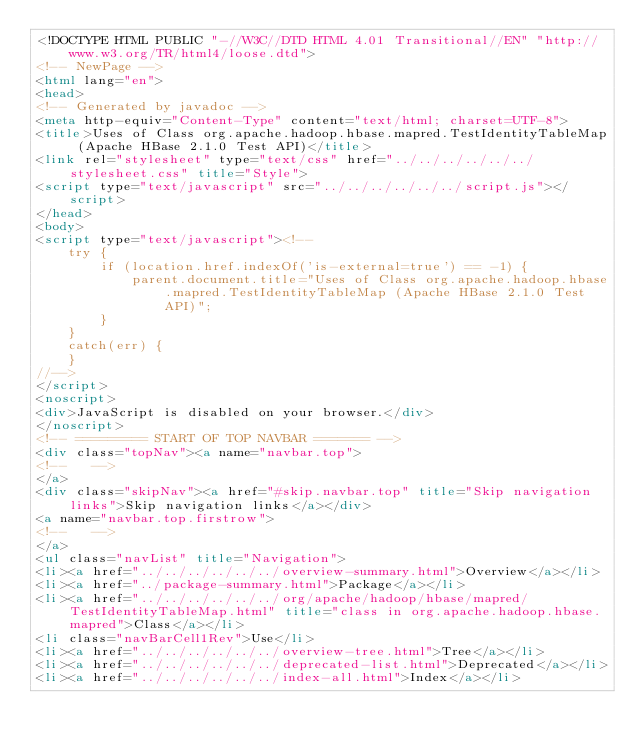<code> <loc_0><loc_0><loc_500><loc_500><_HTML_><!DOCTYPE HTML PUBLIC "-//W3C//DTD HTML 4.01 Transitional//EN" "http://www.w3.org/TR/html4/loose.dtd">
<!-- NewPage -->
<html lang="en">
<head>
<!-- Generated by javadoc -->
<meta http-equiv="Content-Type" content="text/html; charset=UTF-8">
<title>Uses of Class org.apache.hadoop.hbase.mapred.TestIdentityTableMap (Apache HBase 2.1.0 Test API)</title>
<link rel="stylesheet" type="text/css" href="../../../../../../stylesheet.css" title="Style">
<script type="text/javascript" src="../../../../../../script.js"></script>
</head>
<body>
<script type="text/javascript"><!--
    try {
        if (location.href.indexOf('is-external=true') == -1) {
            parent.document.title="Uses of Class org.apache.hadoop.hbase.mapred.TestIdentityTableMap (Apache HBase 2.1.0 Test API)";
        }
    }
    catch(err) {
    }
//-->
</script>
<noscript>
<div>JavaScript is disabled on your browser.</div>
</noscript>
<!-- ========= START OF TOP NAVBAR ======= -->
<div class="topNav"><a name="navbar.top">
<!--   -->
</a>
<div class="skipNav"><a href="#skip.navbar.top" title="Skip navigation links">Skip navigation links</a></div>
<a name="navbar.top.firstrow">
<!--   -->
</a>
<ul class="navList" title="Navigation">
<li><a href="../../../../../../overview-summary.html">Overview</a></li>
<li><a href="../package-summary.html">Package</a></li>
<li><a href="../../../../../../org/apache/hadoop/hbase/mapred/TestIdentityTableMap.html" title="class in org.apache.hadoop.hbase.mapred">Class</a></li>
<li class="navBarCell1Rev">Use</li>
<li><a href="../../../../../../overview-tree.html">Tree</a></li>
<li><a href="../../../../../../deprecated-list.html">Deprecated</a></li>
<li><a href="../../../../../../index-all.html">Index</a></li></code> 